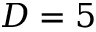Convert formula to latex. <formula><loc_0><loc_0><loc_500><loc_500>D = 5</formula> 